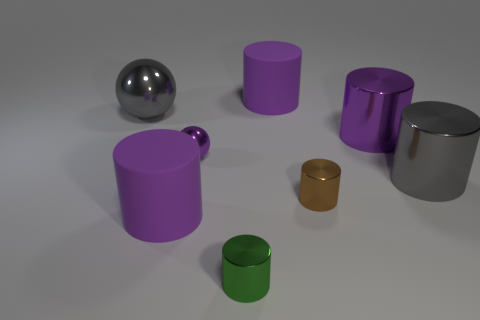How many purple cylinders must be subtracted to get 2 purple cylinders? 1 Subtract all cylinders. How many objects are left? 2 Subtract all tiny green cylinders. How many cylinders are left? 5 Subtract 2 cylinders. How many cylinders are left? 4 Subtract all brown cylinders. How many cylinders are left? 5 Subtract all blue cylinders. Subtract all gray cubes. How many cylinders are left? 6 Subtract all green spheres. How many purple cylinders are left? 3 Subtract all large yellow rubber cylinders. Subtract all small purple metal balls. How many objects are left? 7 Add 4 gray balls. How many gray balls are left? 5 Add 5 large gray balls. How many large gray balls exist? 6 